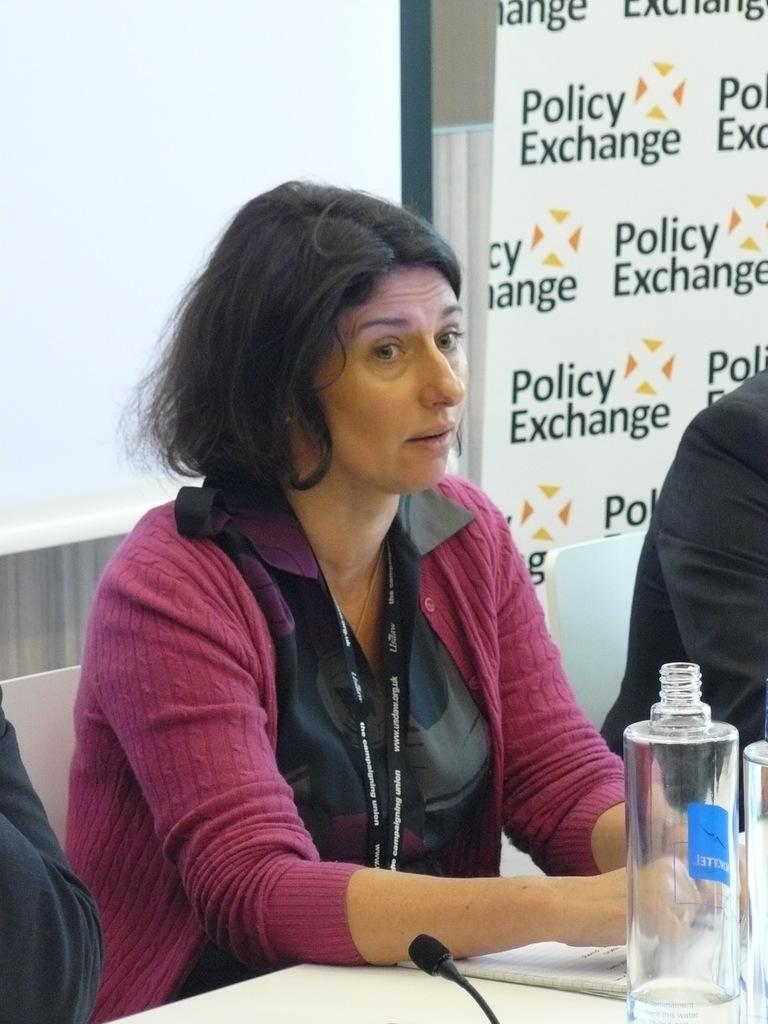<image>
Relay a brief, clear account of the picture shown. A speaker sitting at a table with a sign that reads 'Policy Exchange' on it. 